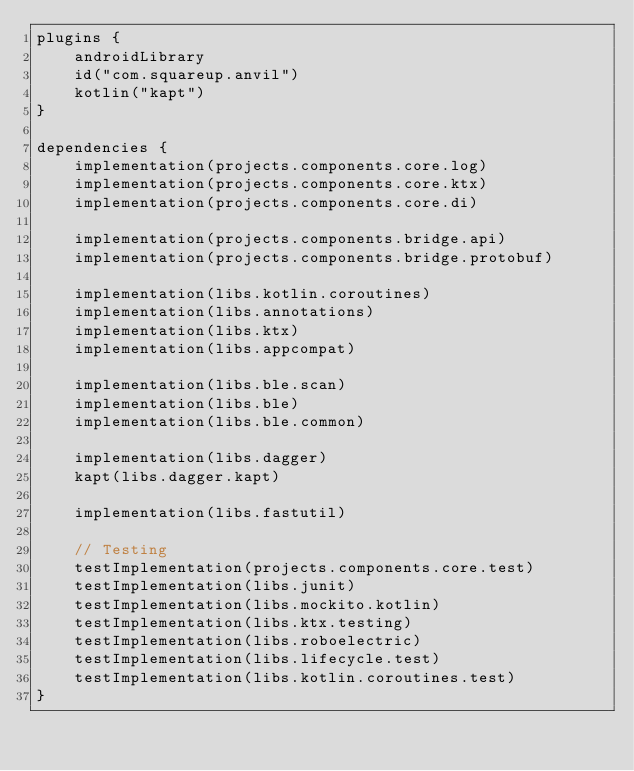Convert code to text. <code><loc_0><loc_0><loc_500><loc_500><_Kotlin_>plugins {
    androidLibrary
    id("com.squareup.anvil")
    kotlin("kapt")
}

dependencies {
    implementation(projects.components.core.log)
    implementation(projects.components.core.ktx)
    implementation(projects.components.core.di)

    implementation(projects.components.bridge.api)
    implementation(projects.components.bridge.protobuf)

    implementation(libs.kotlin.coroutines)
    implementation(libs.annotations)
    implementation(libs.ktx)
    implementation(libs.appcompat)

    implementation(libs.ble.scan)
    implementation(libs.ble)
    implementation(libs.ble.common)

    implementation(libs.dagger)
    kapt(libs.dagger.kapt)

    implementation(libs.fastutil)

    // Testing
    testImplementation(projects.components.core.test)
    testImplementation(libs.junit)
    testImplementation(libs.mockito.kotlin)
    testImplementation(libs.ktx.testing)
    testImplementation(libs.roboelectric)
    testImplementation(libs.lifecycle.test)
    testImplementation(libs.kotlin.coroutines.test)
}
</code> 